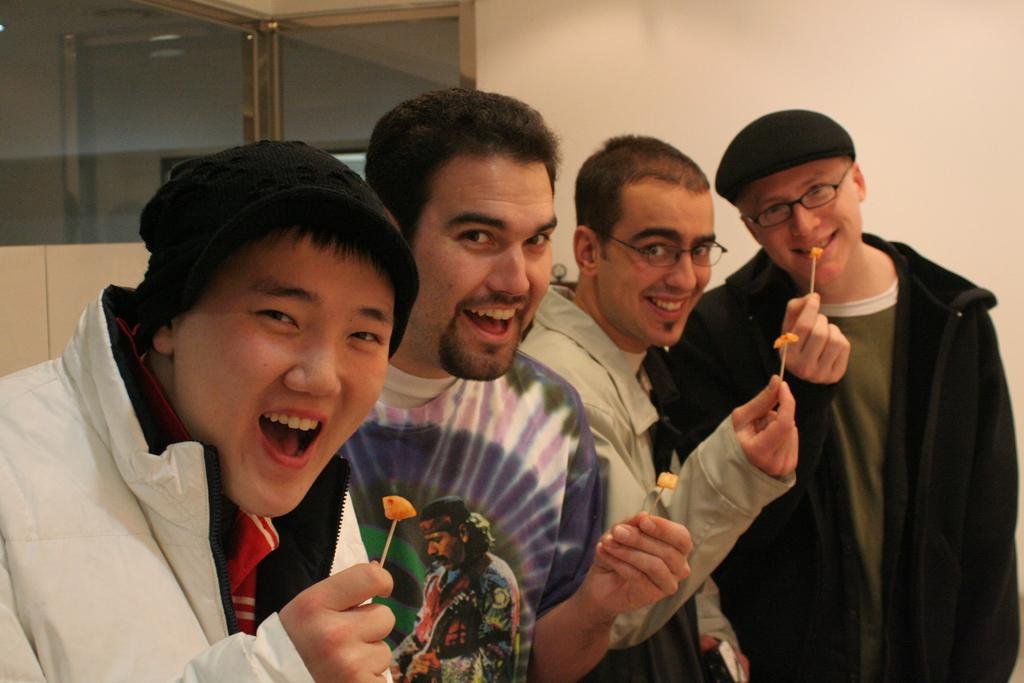How many people are in the image? There are four men in the image. What are the men doing in the image? The men are standing and smiling. What objects are the men holding in their hands? The men are holding toothpicks in their hands. What can be seen behind the men in the image? There is a glass door and a white wall in the image. What type of song can be heard being sung by the men in the image? There is no indication in the image that the men are singing, so it cannot be determined from the picture. 